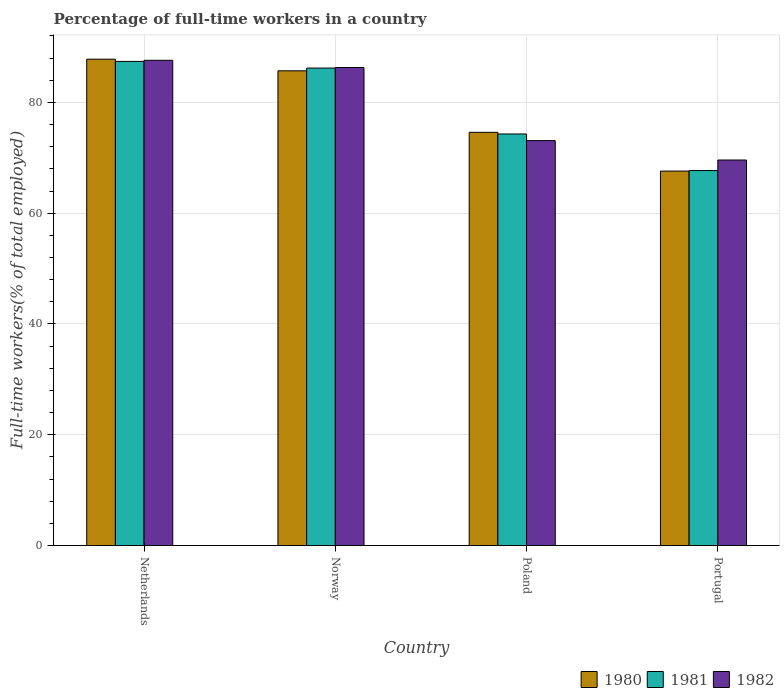How many groups of bars are there?
Ensure brevity in your answer.  4. Are the number of bars per tick equal to the number of legend labels?
Ensure brevity in your answer.  Yes. Are the number of bars on each tick of the X-axis equal?
Ensure brevity in your answer.  Yes. How many bars are there on the 3rd tick from the left?
Make the answer very short. 3. How many bars are there on the 3rd tick from the right?
Keep it short and to the point. 3. What is the percentage of full-time workers in 1980 in Netherlands?
Offer a terse response. 87.8. Across all countries, what is the maximum percentage of full-time workers in 1981?
Ensure brevity in your answer.  87.4. Across all countries, what is the minimum percentage of full-time workers in 1982?
Ensure brevity in your answer.  69.6. What is the total percentage of full-time workers in 1981 in the graph?
Ensure brevity in your answer.  315.6. What is the difference between the percentage of full-time workers in 1980 in Netherlands and that in Portugal?
Provide a succinct answer. 20.2. What is the difference between the percentage of full-time workers in 1982 in Portugal and the percentage of full-time workers in 1981 in Poland?
Make the answer very short. -4.7. What is the average percentage of full-time workers in 1981 per country?
Give a very brief answer. 78.9. What is the difference between the percentage of full-time workers of/in 1982 and percentage of full-time workers of/in 1980 in Norway?
Offer a very short reply. 0.6. What is the ratio of the percentage of full-time workers in 1982 in Netherlands to that in Portugal?
Your response must be concise. 1.26. What is the difference between the highest and the second highest percentage of full-time workers in 1982?
Give a very brief answer. -13.2. What is the difference between the highest and the lowest percentage of full-time workers in 1980?
Your response must be concise. 20.2. In how many countries, is the percentage of full-time workers in 1982 greater than the average percentage of full-time workers in 1982 taken over all countries?
Offer a terse response. 2. Is the sum of the percentage of full-time workers in 1982 in Poland and Portugal greater than the maximum percentage of full-time workers in 1980 across all countries?
Your answer should be compact. Yes. What does the 3rd bar from the left in Netherlands represents?
Ensure brevity in your answer.  1982. What does the 1st bar from the right in Netherlands represents?
Your answer should be very brief. 1982. Is it the case that in every country, the sum of the percentage of full-time workers in 1982 and percentage of full-time workers in 1981 is greater than the percentage of full-time workers in 1980?
Offer a terse response. Yes. How many countries are there in the graph?
Offer a very short reply. 4. Does the graph contain grids?
Ensure brevity in your answer.  Yes. Where does the legend appear in the graph?
Ensure brevity in your answer.  Bottom right. What is the title of the graph?
Your answer should be very brief. Percentage of full-time workers in a country. Does "1979" appear as one of the legend labels in the graph?
Provide a short and direct response. No. What is the label or title of the Y-axis?
Give a very brief answer. Full-time workers(% of total employed). What is the Full-time workers(% of total employed) in 1980 in Netherlands?
Make the answer very short. 87.8. What is the Full-time workers(% of total employed) in 1981 in Netherlands?
Your response must be concise. 87.4. What is the Full-time workers(% of total employed) of 1982 in Netherlands?
Provide a succinct answer. 87.6. What is the Full-time workers(% of total employed) in 1980 in Norway?
Provide a succinct answer. 85.7. What is the Full-time workers(% of total employed) of 1981 in Norway?
Offer a very short reply. 86.2. What is the Full-time workers(% of total employed) in 1982 in Norway?
Provide a short and direct response. 86.3. What is the Full-time workers(% of total employed) in 1980 in Poland?
Your answer should be compact. 74.6. What is the Full-time workers(% of total employed) of 1981 in Poland?
Provide a succinct answer. 74.3. What is the Full-time workers(% of total employed) in 1982 in Poland?
Offer a terse response. 73.1. What is the Full-time workers(% of total employed) in 1980 in Portugal?
Make the answer very short. 67.6. What is the Full-time workers(% of total employed) of 1981 in Portugal?
Provide a short and direct response. 67.7. What is the Full-time workers(% of total employed) in 1982 in Portugal?
Keep it short and to the point. 69.6. Across all countries, what is the maximum Full-time workers(% of total employed) in 1980?
Your answer should be compact. 87.8. Across all countries, what is the maximum Full-time workers(% of total employed) of 1981?
Your answer should be very brief. 87.4. Across all countries, what is the maximum Full-time workers(% of total employed) of 1982?
Your response must be concise. 87.6. Across all countries, what is the minimum Full-time workers(% of total employed) in 1980?
Provide a succinct answer. 67.6. Across all countries, what is the minimum Full-time workers(% of total employed) in 1981?
Give a very brief answer. 67.7. Across all countries, what is the minimum Full-time workers(% of total employed) of 1982?
Provide a succinct answer. 69.6. What is the total Full-time workers(% of total employed) of 1980 in the graph?
Offer a very short reply. 315.7. What is the total Full-time workers(% of total employed) in 1981 in the graph?
Make the answer very short. 315.6. What is the total Full-time workers(% of total employed) in 1982 in the graph?
Your answer should be very brief. 316.6. What is the difference between the Full-time workers(% of total employed) in 1982 in Netherlands and that in Norway?
Ensure brevity in your answer.  1.3. What is the difference between the Full-time workers(% of total employed) in 1980 in Netherlands and that in Poland?
Your response must be concise. 13.2. What is the difference between the Full-time workers(% of total employed) in 1982 in Netherlands and that in Poland?
Your answer should be very brief. 14.5. What is the difference between the Full-time workers(% of total employed) in 1980 in Netherlands and that in Portugal?
Your answer should be very brief. 20.2. What is the difference between the Full-time workers(% of total employed) of 1981 in Netherlands and that in Portugal?
Keep it short and to the point. 19.7. What is the difference between the Full-time workers(% of total employed) of 1981 in Norway and that in Poland?
Offer a very short reply. 11.9. What is the difference between the Full-time workers(% of total employed) of 1980 in Norway and that in Portugal?
Give a very brief answer. 18.1. What is the difference between the Full-time workers(% of total employed) in 1981 in Norway and that in Portugal?
Your answer should be compact. 18.5. What is the difference between the Full-time workers(% of total employed) of 1980 in Poland and that in Portugal?
Offer a very short reply. 7. What is the difference between the Full-time workers(% of total employed) in 1981 in Poland and that in Portugal?
Your answer should be very brief. 6.6. What is the difference between the Full-time workers(% of total employed) of 1980 in Netherlands and the Full-time workers(% of total employed) of 1981 in Norway?
Keep it short and to the point. 1.6. What is the difference between the Full-time workers(% of total employed) in 1980 in Netherlands and the Full-time workers(% of total employed) in 1981 in Poland?
Ensure brevity in your answer.  13.5. What is the difference between the Full-time workers(% of total employed) in 1981 in Netherlands and the Full-time workers(% of total employed) in 1982 in Poland?
Make the answer very short. 14.3. What is the difference between the Full-time workers(% of total employed) of 1980 in Netherlands and the Full-time workers(% of total employed) of 1981 in Portugal?
Provide a succinct answer. 20.1. What is the difference between the Full-time workers(% of total employed) of 1980 in Norway and the Full-time workers(% of total employed) of 1981 in Portugal?
Give a very brief answer. 18. What is the difference between the Full-time workers(% of total employed) of 1980 in Norway and the Full-time workers(% of total employed) of 1982 in Portugal?
Ensure brevity in your answer.  16.1. What is the difference between the Full-time workers(% of total employed) of 1981 in Norway and the Full-time workers(% of total employed) of 1982 in Portugal?
Give a very brief answer. 16.6. What is the difference between the Full-time workers(% of total employed) in 1980 in Poland and the Full-time workers(% of total employed) in 1982 in Portugal?
Provide a succinct answer. 5. What is the difference between the Full-time workers(% of total employed) in 1981 in Poland and the Full-time workers(% of total employed) in 1982 in Portugal?
Offer a very short reply. 4.7. What is the average Full-time workers(% of total employed) in 1980 per country?
Offer a terse response. 78.92. What is the average Full-time workers(% of total employed) in 1981 per country?
Provide a succinct answer. 78.9. What is the average Full-time workers(% of total employed) in 1982 per country?
Keep it short and to the point. 79.15. What is the difference between the Full-time workers(% of total employed) in 1980 and Full-time workers(% of total employed) in 1982 in Norway?
Offer a very short reply. -0.6. What is the difference between the Full-time workers(% of total employed) of 1981 and Full-time workers(% of total employed) of 1982 in Norway?
Give a very brief answer. -0.1. What is the difference between the Full-time workers(% of total employed) in 1980 and Full-time workers(% of total employed) in 1981 in Poland?
Offer a terse response. 0.3. What is the difference between the Full-time workers(% of total employed) in 1980 and Full-time workers(% of total employed) in 1981 in Portugal?
Keep it short and to the point. -0.1. What is the ratio of the Full-time workers(% of total employed) in 1980 in Netherlands to that in Norway?
Ensure brevity in your answer.  1.02. What is the ratio of the Full-time workers(% of total employed) of 1981 in Netherlands to that in Norway?
Make the answer very short. 1.01. What is the ratio of the Full-time workers(% of total employed) in 1982 in Netherlands to that in Norway?
Provide a short and direct response. 1.02. What is the ratio of the Full-time workers(% of total employed) in 1980 in Netherlands to that in Poland?
Your answer should be very brief. 1.18. What is the ratio of the Full-time workers(% of total employed) in 1981 in Netherlands to that in Poland?
Offer a terse response. 1.18. What is the ratio of the Full-time workers(% of total employed) in 1982 in Netherlands to that in Poland?
Your response must be concise. 1.2. What is the ratio of the Full-time workers(% of total employed) in 1980 in Netherlands to that in Portugal?
Your response must be concise. 1.3. What is the ratio of the Full-time workers(% of total employed) in 1981 in Netherlands to that in Portugal?
Offer a terse response. 1.29. What is the ratio of the Full-time workers(% of total employed) of 1982 in Netherlands to that in Portugal?
Provide a short and direct response. 1.26. What is the ratio of the Full-time workers(% of total employed) in 1980 in Norway to that in Poland?
Make the answer very short. 1.15. What is the ratio of the Full-time workers(% of total employed) in 1981 in Norway to that in Poland?
Your answer should be compact. 1.16. What is the ratio of the Full-time workers(% of total employed) in 1982 in Norway to that in Poland?
Provide a succinct answer. 1.18. What is the ratio of the Full-time workers(% of total employed) of 1980 in Norway to that in Portugal?
Give a very brief answer. 1.27. What is the ratio of the Full-time workers(% of total employed) in 1981 in Norway to that in Portugal?
Your response must be concise. 1.27. What is the ratio of the Full-time workers(% of total employed) of 1982 in Norway to that in Portugal?
Provide a short and direct response. 1.24. What is the ratio of the Full-time workers(% of total employed) in 1980 in Poland to that in Portugal?
Ensure brevity in your answer.  1.1. What is the ratio of the Full-time workers(% of total employed) in 1981 in Poland to that in Portugal?
Offer a terse response. 1.1. What is the ratio of the Full-time workers(% of total employed) of 1982 in Poland to that in Portugal?
Your answer should be very brief. 1.05. What is the difference between the highest and the second highest Full-time workers(% of total employed) of 1980?
Your answer should be compact. 2.1. What is the difference between the highest and the second highest Full-time workers(% of total employed) of 1981?
Provide a short and direct response. 1.2. What is the difference between the highest and the lowest Full-time workers(% of total employed) of 1980?
Offer a very short reply. 20.2. What is the difference between the highest and the lowest Full-time workers(% of total employed) of 1981?
Provide a succinct answer. 19.7. What is the difference between the highest and the lowest Full-time workers(% of total employed) in 1982?
Your answer should be very brief. 18. 